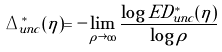Convert formula to latex. <formula><loc_0><loc_0><loc_500><loc_500>\Delta ^ { * } _ { u n c } ( \eta ) = - \lim _ { \rho \rightarrow \infty } \frac { \log E D ^ { * } _ { u n c } ( \eta ) } { \log \rho }</formula> 